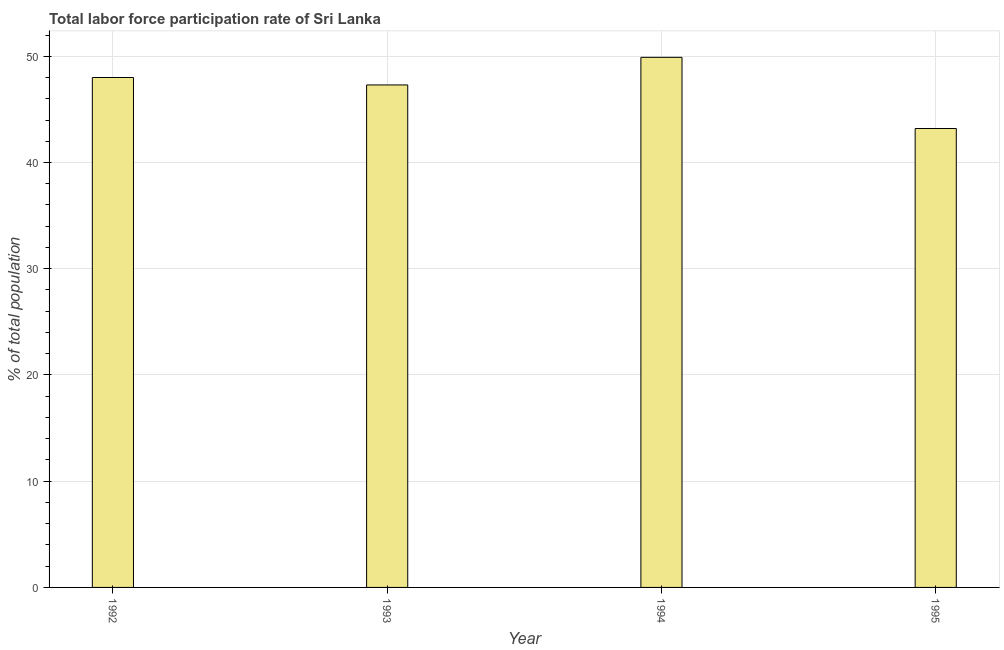What is the title of the graph?
Keep it short and to the point. Total labor force participation rate of Sri Lanka. What is the label or title of the Y-axis?
Your response must be concise. % of total population. What is the total labor force participation rate in 1993?
Your answer should be very brief. 47.3. Across all years, what is the maximum total labor force participation rate?
Your answer should be compact. 49.9. Across all years, what is the minimum total labor force participation rate?
Provide a succinct answer. 43.2. In which year was the total labor force participation rate maximum?
Keep it short and to the point. 1994. What is the sum of the total labor force participation rate?
Give a very brief answer. 188.4. What is the average total labor force participation rate per year?
Offer a terse response. 47.1. What is the median total labor force participation rate?
Provide a succinct answer. 47.65. Do a majority of the years between 1992 and 1994 (inclusive) have total labor force participation rate greater than 30 %?
Your answer should be compact. Yes. What is the ratio of the total labor force participation rate in 1992 to that in 1993?
Your answer should be very brief. 1.01. What is the difference between the highest and the second highest total labor force participation rate?
Provide a succinct answer. 1.9. Is the sum of the total labor force participation rate in 1993 and 1994 greater than the maximum total labor force participation rate across all years?
Your answer should be very brief. Yes. In how many years, is the total labor force participation rate greater than the average total labor force participation rate taken over all years?
Your response must be concise. 3. How many bars are there?
Your response must be concise. 4. What is the % of total population in 1992?
Offer a very short reply. 48. What is the % of total population of 1993?
Offer a terse response. 47.3. What is the % of total population in 1994?
Ensure brevity in your answer.  49.9. What is the % of total population of 1995?
Give a very brief answer. 43.2. What is the difference between the % of total population in 1993 and 1994?
Your answer should be compact. -2.6. What is the difference between the % of total population in 1993 and 1995?
Ensure brevity in your answer.  4.1. What is the difference between the % of total population in 1994 and 1995?
Offer a terse response. 6.7. What is the ratio of the % of total population in 1992 to that in 1995?
Offer a very short reply. 1.11. What is the ratio of the % of total population in 1993 to that in 1994?
Your answer should be compact. 0.95. What is the ratio of the % of total population in 1993 to that in 1995?
Your answer should be very brief. 1.09. What is the ratio of the % of total population in 1994 to that in 1995?
Offer a very short reply. 1.16. 